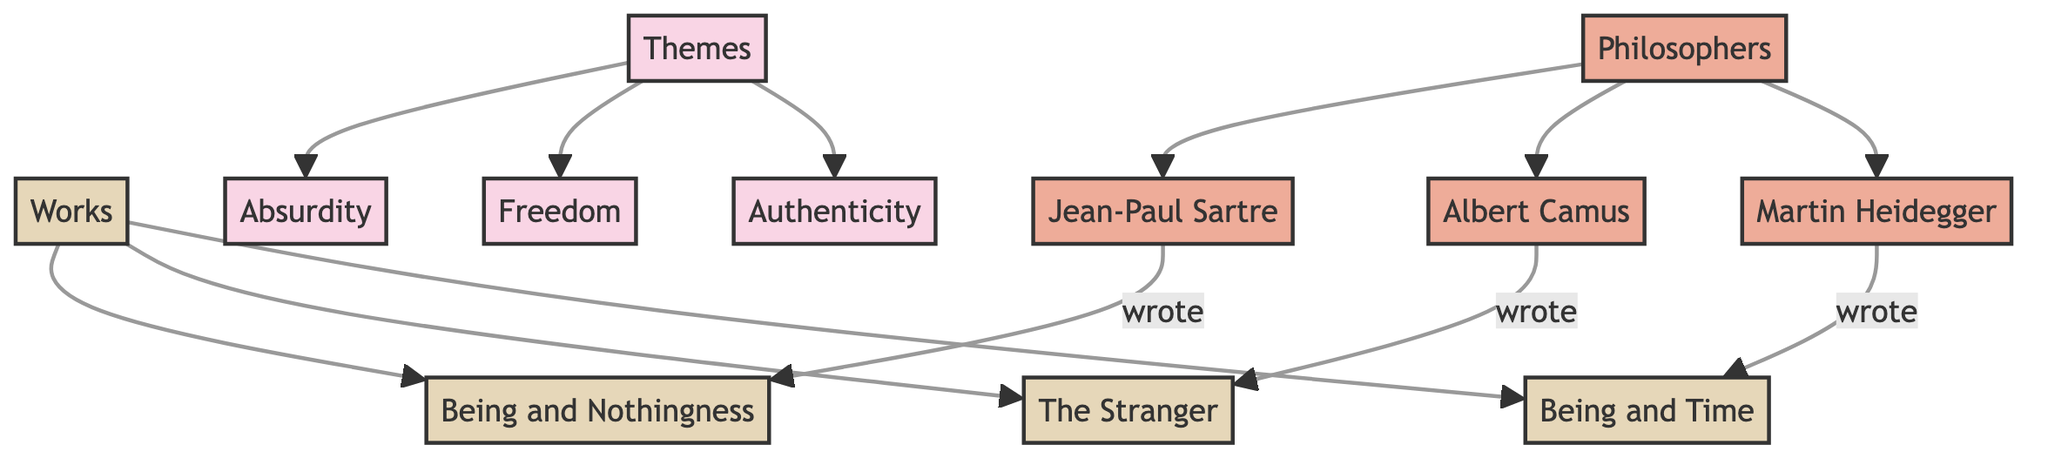What are the three main themes in the diagram? The themes are explicitly listed as nodes under "Themes" in the diagram, which includes Absurdity, Freedom, and Authenticity.
Answer: Absurdity, Freedom, Authenticity How many philosophers are represented in the diagram? There are three philosophers in the diagram: Jean-Paul Sartre, Albert Camus, and Martin Heidegger, all connected under the "Philosophers" node.
Answer: 3 Which philosopher wrote "Being and Nothingness"? The diagram indicates that Jean-Paul Sartre is connected to the work "Being and Nothingness" through a directed edge marked "wrote."
Answer: Jean-Paul Sartre Which theme is connected to both "Absurdity" and "Freedom"? The node "Themes" connects directly to both Absurdity and Freedom, indicating that they are part of the same overarching category.
Answer: Themes What is the relationship between "Camus" and "The Stranger"? The diagram shows a directed edge from the philosopher "Camus" to the work "The Stranger," labeled "wrote," indicating Camus authored this work.
Answer: wrote How many works are mentioned in the diagram? The diagram shows three distinct works: "Being and Nothingness," "The Stranger," and "Being and Time," each connected under the "Works" node.
Answer: 3 Which philosopher is associated with "Being and Time"? Martin Heidegger has a direct connection in the diagram to the work "Being and Time," indicating he is the author of this philosophical text.
Answer: Martin Heidegger What aspect of existentialism is represented by the theme "Authenticity"? "Authenticity" is listed as one of the central themes under "Themes," which reflects a fundamental concept in existential thought about being true to oneself amidst societal pressures.
Answer: Authenticity What is the color code used for the themes in the diagram? The color code for the themes is defined in the code with a fill of light pink (#f9d5e5), highlighting that these nodes represent themes within existentialism.
Answer: Light pink 